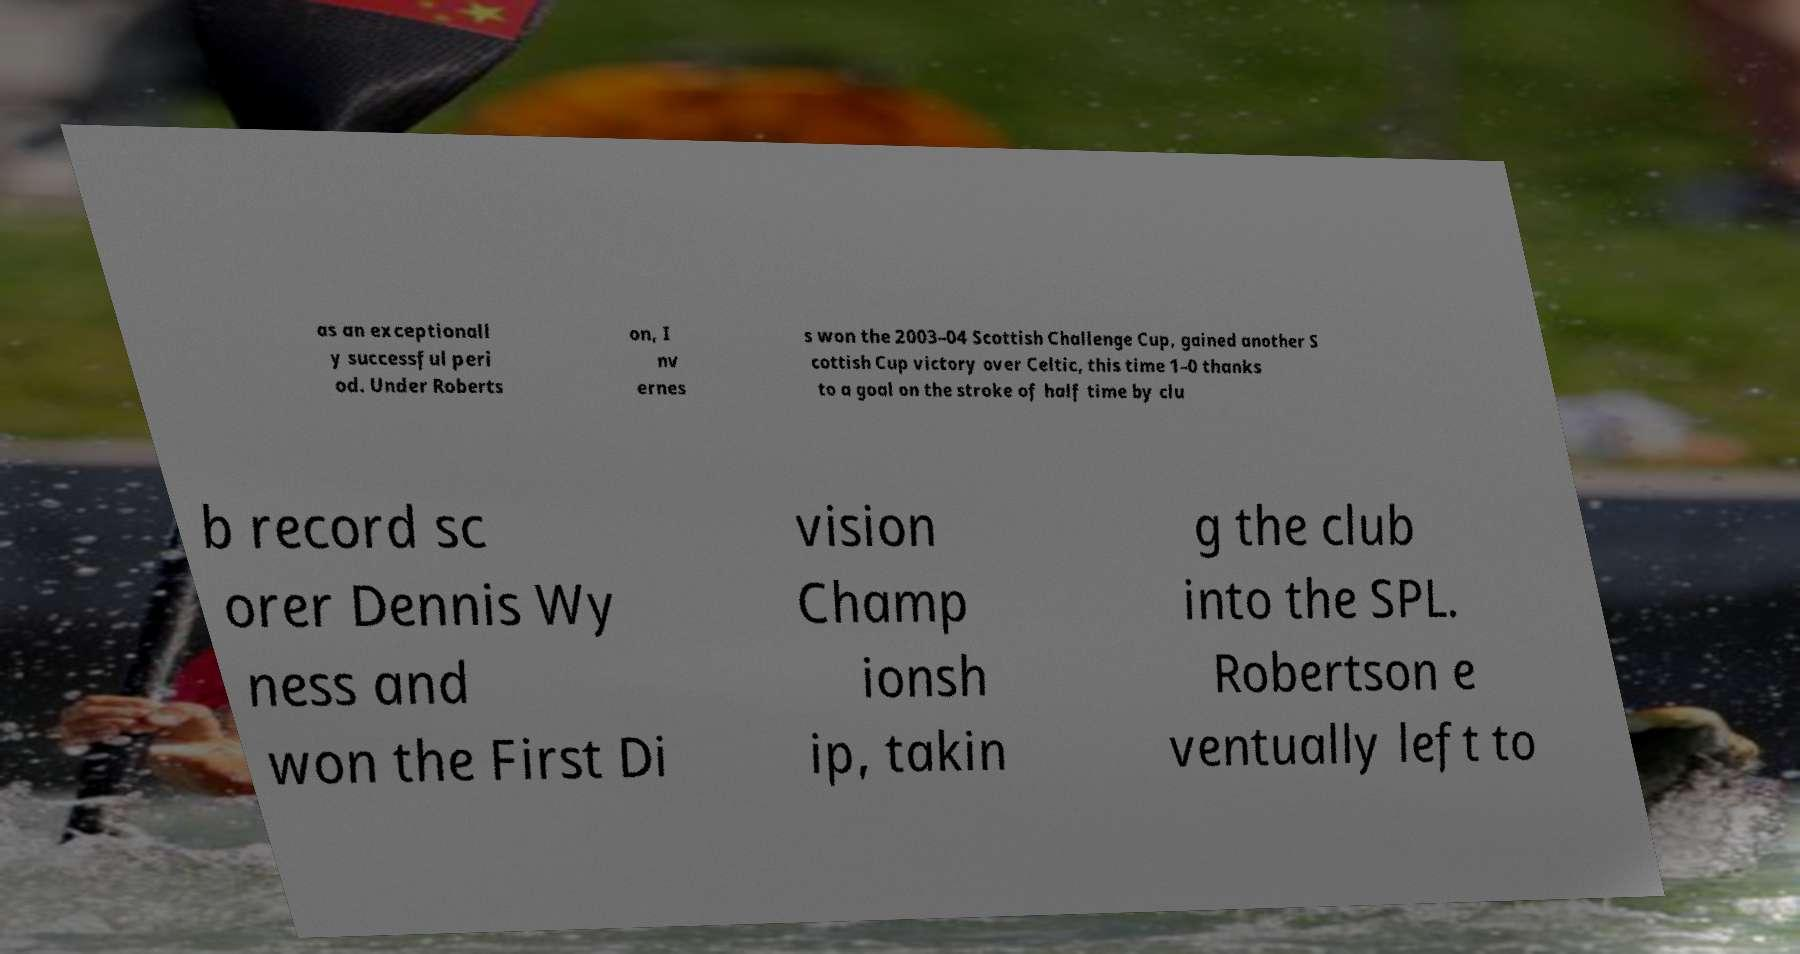Please read and relay the text visible in this image. What does it say? as an exceptionall y successful peri od. Under Roberts on, I nv ernes s won the 2003–04 Scottish Challenge Cup, gained another S cottish Cup victory over Celtic, this time 1–0 thanks to a goal on the stroke of half time by clu b record sc orer Dennis Wy ness and won the First Di vision Champ ionsh ip, takin g the club into the SPL. Robertson e ventually left to 